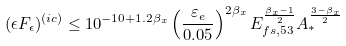<formula> <loc_0><loc_0><loc_500><loc_500>( \epsilon F _ { \epsilon } ) ^ { ( i c ) } \leq 1 0 ^ { - 1 0 + 1 . 2 \beta _ { x } } \left ( \frac { \varepsilon _ { e } } { 0 . 0 5 } \right ) ^ { 2 \beta _ { x } } E _ { f s , 5 3 } ^ { \frac { \beta _ { x } - 1 } { 2 } } A _ { * } ^ { \frac { 3 - \beta _ { x } } { 2 } }</formula> 